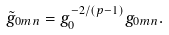<formula> <loc_0><loc_0><loc_500><loc_500>\tilde { g } _ { 0 m n } = g ^ { - 2 / ( p - 1 ) } _ { 0 } g _ { 0 m n } .</formula> 